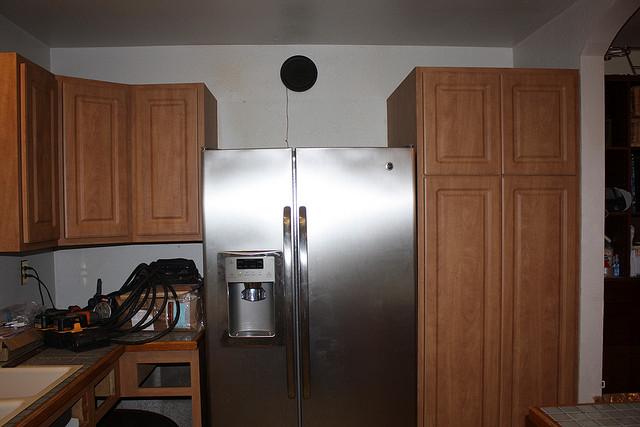What color are the walls?
Quick response, please. White. Are there any ceiling lamps in this kitchen?
Keep it brief. No. How many different colors are in this picture?
Write a very short answer. 5. What room is this?
Keep it brief. Kitchen. Is the fridge white?
Be succinct. No. Is the counter cluttered?
Quick response, please. Yes. 